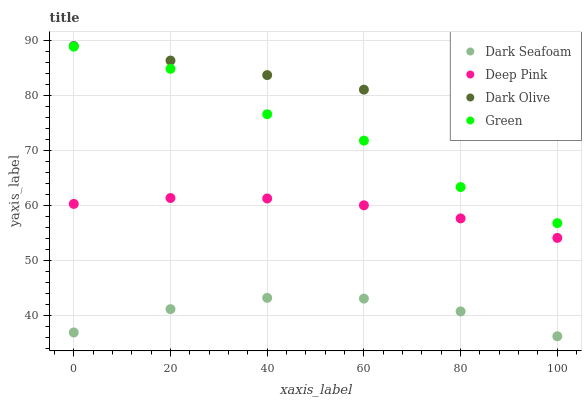Does Dark Seafoam have the minimum area under the curve?
Answer yes or no. Yes. Does Dark Olive have the maximum area under the curve?
Answer yes or no. Yes. Does Deep Pink have the minimum area under the curve?
Answer yes or no. No. Does Deep Pink have the maximum area under the curve?
Answer yes or no. No. Is Dark Olive the smoothest?
Answer yes or no. Yes. Is Green the roughest?
Answer yes or no. Yes. Is Dark Seafoam the smoothest?
Answer yes or no. No. Is Dark Seafoam the roughest?
Answer yes or no. No. Does Dark Seafoam have the lowest value?
Answer yes or no. Yes. Does Deep Pink have the lowest value?
Answer yes or no. No. Does Dark Olive have the highest value?
Answer yes or no. Yes. Does Deep Pink have the highest value?
Answer yes or no. No. Is Dark Seafoam less than Dark Olive?
Answer yes or no. Yes. Is Dark Olive greater than Green?
Answer yes or no. Yes. Does Dark Seafoam intersect Dark Olive?
Answer yes or no. No. 